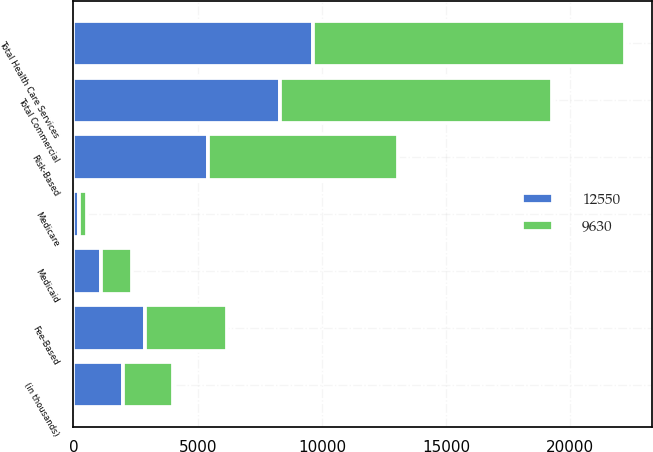<chart> <loc_0><loc_0><loc_500><loc_500><stacked_bar_chart><ecel><fcel>(in thousands)<fcel>Risk-Based<fcel>Fee-Based<fcel>Total Commercial<fcel>Medicare<fcel>Medicaid<fcel>Total Health Care Services<nl><fcel>9630<fcel>2004<fcel>7655<fcel>3305<fcel>10960<fcel>330<fcel>1260<fcel>12550<nl><fcel>12550<fcel>2003<fcel>5400<fcel>2895<fcel>8295<fcel>230<fcel>1105<fcel>9630<nl></chart> 